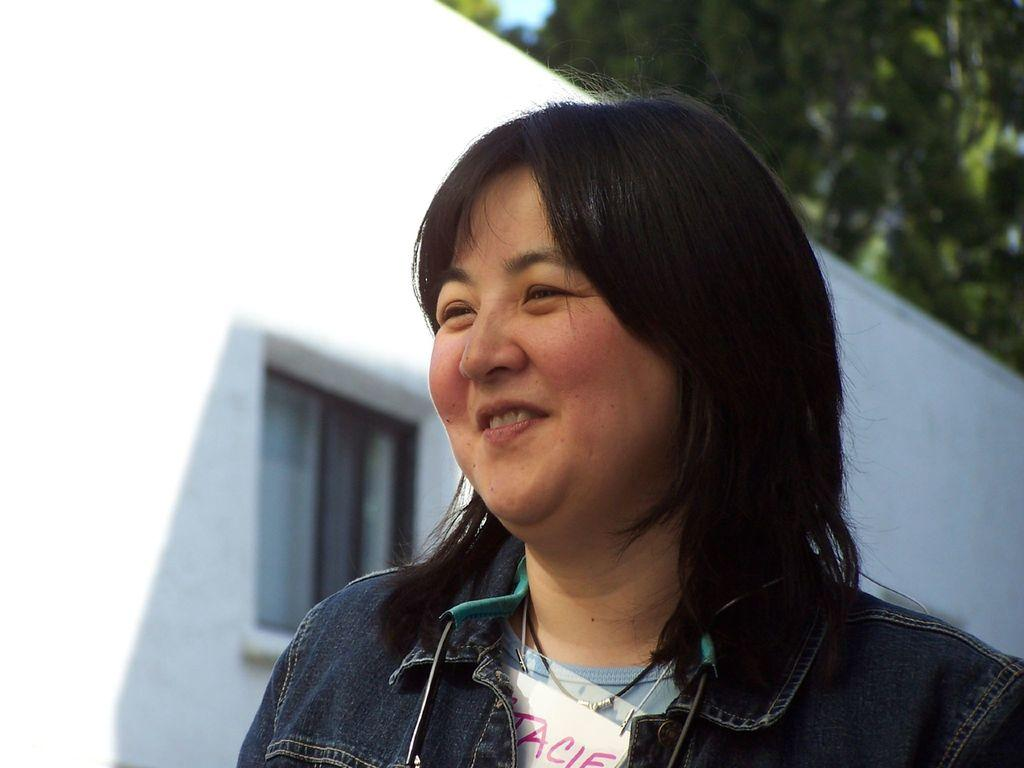Who is present in the image? There is a woman in the image. What is the woman wearing? The woman is wearing a blue T-shirt and a blue jacket. What is the woman's facial expression? The woman is smiling. What can be seen in the background of the image? There are trees in the background of the image. What type of potato is being used to start the engine in the image? There is no potato or engine present in the image. What type of celery can be seen growing in the background of the image? There is no celery present in the image; only trees are visible in the background. 